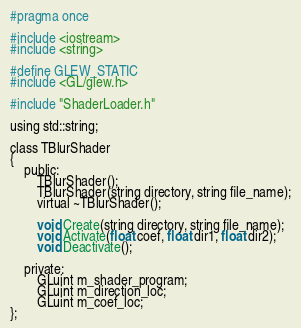Convert code to text. <code><loc_0><loc_0><loc_500><loc_500><_C_>#pragma once

#include <iostream>
#include <string>

#define GLEW_STATIC
#include <GL/glew.h>

#include "ShaderLoader.h"

using std::string;

class TBlurShader
{
    public:
        TBlurShader();
        TBlurShader(string directory, string file_name);
        virtual ~TBlurShader();

        void Create(string directory, string file_name);
        void Activate(float coef, float dir1, float dir2);
        void Deactivate();

    private:
        GLuint m_shader_program;
        GLuint m_direction_loc;
        GLuint m_coef_loc;
};
</code> 